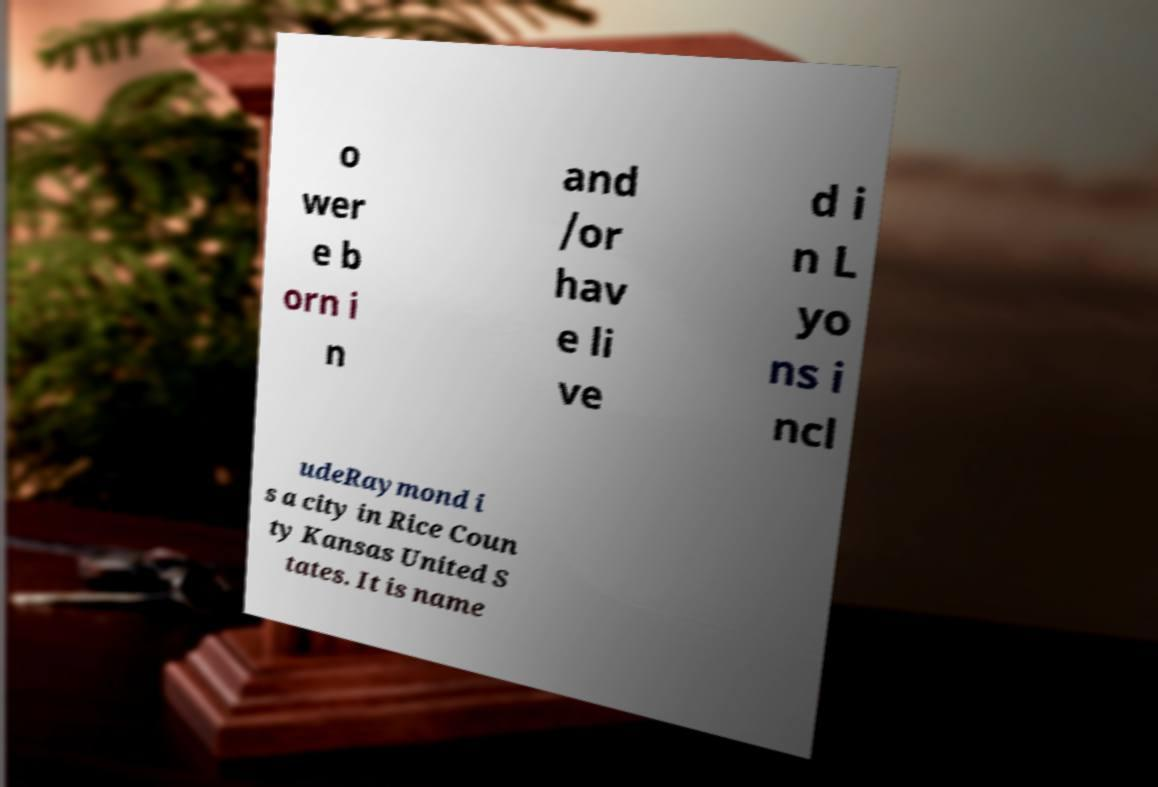I need the written content from this picture converted into text. Can you do that? o wer e b orn i n and /or hav e li ve d i n L yo ns i ncl udeRaymond i s a city in Rice Coun ty Kansas United S tates. It is name 